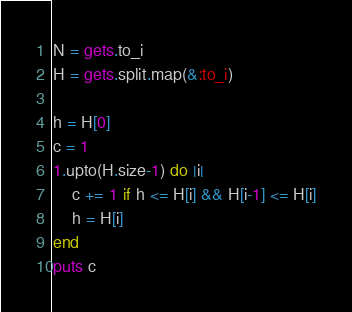<code> <loc_0><loc_0><loc_500><loc_500><_Ruby_>N = gets.to_i
H = gets.split.map(&:to_i)

h = H[0]
c = 1
1.upto(H.size-1) do |i|
    c += 1 if h <= H[i] && H[i-1] <= H[i]
    h = H[i]
end
puts c</code> 